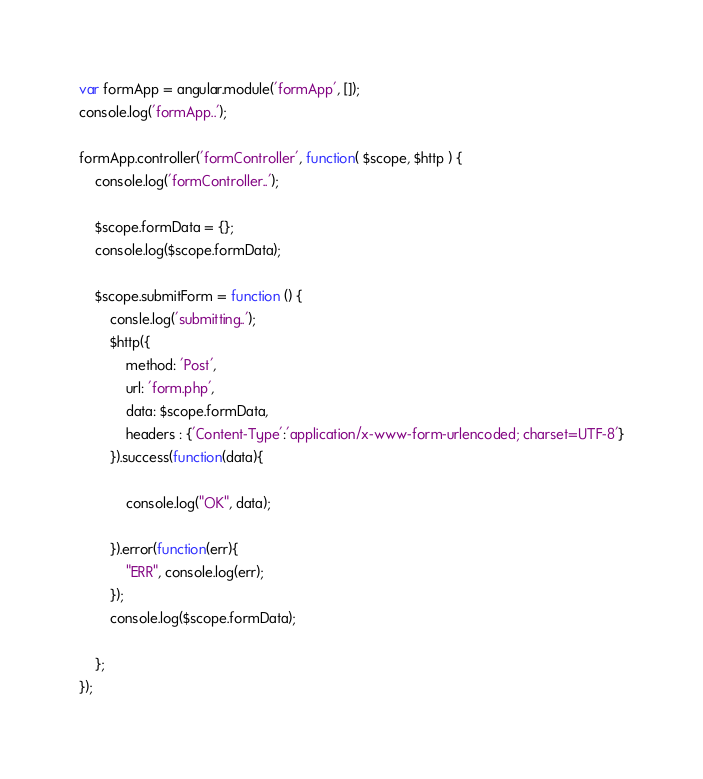<code> <loc_0><loc_0><loc_500><loc_500><_JavaScript_>var formApp = angular.module('formApp', []);
console.log('formApp..');

formApp.controller('formController', function( $scope, $http ) {
    console.log('formController..');

    $scope.formData = {};
    console.log($scope.formData);

    $scope.submitForm = function () {
        consle.log('submitting..');
        $http({
            method: 'Post',
            url: 'form.php',
            data: $scope.formData,
            headers : {'Content-Type':'application/x-www-form-urlencoded; charset=UTF-8'}
        }).success(function(data){

            console.log("OK", data);

        }).error(function(err){
            "ERR", console.log(err);
        });
        console.log($scope.formData);
    
    };
});
</code> 